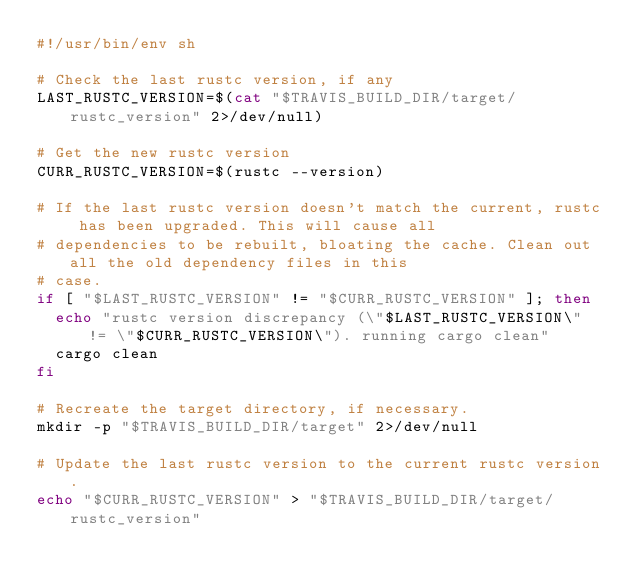Convert code to text. <code><loc_0><loc_0><loc_500><loc_500><_Bash_>#!/usr/bin/env sh

# Check the last rustc version, if any
LAST_RUSTC_VERSION=$(cat "$TRAVIS_BUILD_DIR/target/rustc_version" 2>/dev/null)

# Get the new rustc version
CURR_RUSTC_VERSION=$(rustc --version)

# If the last rustc version doesn't match the current, rustc has been upgraded. This will cause all
# dependencies to be rebuilt, bloating the cache. Clean out all the old dependency files in this
# case.
if [ "$LAST_RUSTC_VERSION" != "$CURR_RUSTC_VERSION" ]; then
  echo "rustc version discrepancy (\"$LAST_RUSTC_VERSION\" != \"$CURR_RUSTC_VERSION\"). running cargo clean"
  cargo clean
fi

# Recreate the target directory, if necessary.
mkdir -p "$TRAVIS_BUILD_DIR/target" 2>/dev/null

# Update the last rustc version to the current rustc version.
echo "$CURR_RUSTC_VERSION" > "$TRAVIS_BUILD_DIR/target/rustc_version"
</code> 